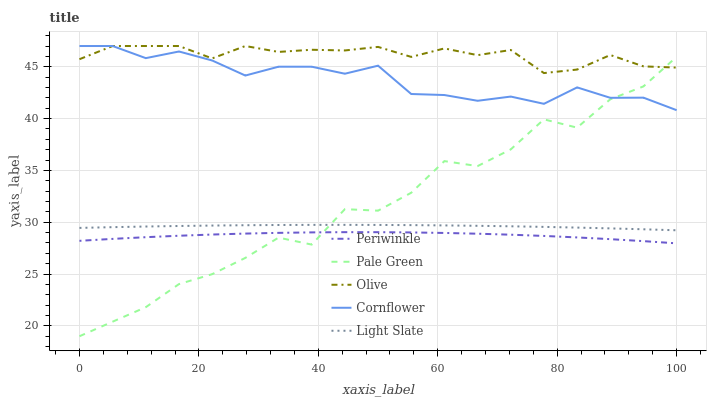Does Periwinkle have the minimum area under the curve?
Answer yes or no. Yes. Does Olive have the maximum area under the curve?
Answer yes or no. Yes. Does Cornflower have the minimum area under the curve?
Answer yes or no. No. Does Cornflower have the maximum area under the curve?
Answer yes or no. No. Is Light Slate the smoothest?
Answer yes or no. Yes. Is Pale Green the roughest?
Answer yes or no. Yes. Is Cornflower the smoothest?
Answer yes or no. No. Is Cornflower the roughest?
Answer yes or no. No. Does Pale Green have the lowest value?
Answer yes or no. Yes. Does Cornflower have the lowest value?
Answer yes or no. No. Does Cornflower have the highest value?
Answer yes or no. Yes. Does Pale Green have the highest value?
Answer yes or no. No. Is Periwinkle less than Cornflower?
Answer yes or no. Yes. Is Olive greater than Light Slate?
Answer yes or no. Yes. Does Olive intersect Cornflower?
Answer yes or no. Yes. Is Olive less than Cornflower?
Answer yes or no. No. Is Olive greater than Cornflower?
Answer yes or no. No. Does Periwinkle intersect Cornflower?
Answer yes or no. No. 